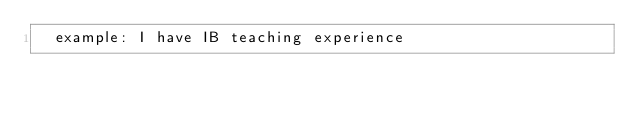<code> <loc_0><loc_0><loc_500><loc_500><_YAML_>  example: I have IB teaching experience
</code> 